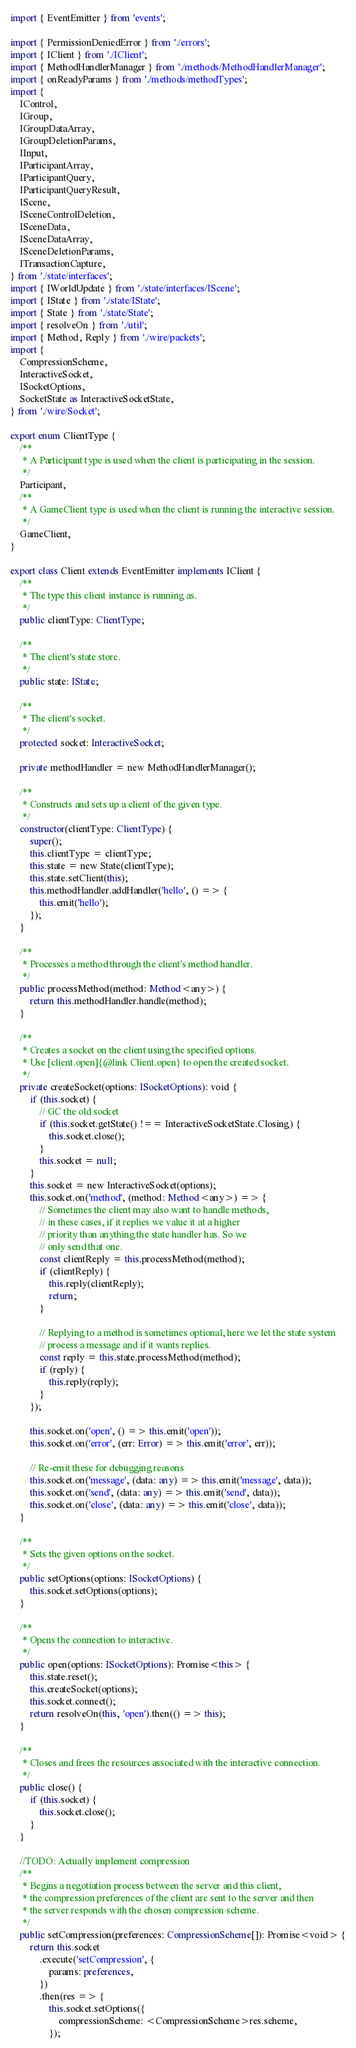<code> <loc_0><loc_0><loc_500><loc_500><_TypeScript_>import { EventEmitter } from 'events';

import { PermissionDeniedError } from './errors';
import { IClient } from './IClient';
import { MethodHandlerManager } from './methods/MethodHandlerManager';
import { onReadyParams } from './methods/methodTypes';
import {
    IControl,
    IGroup,
    IGroupDataArray,
    IGroupDeletionParams,
    IInput,
    IParticipantArray,
    IParticipantQuery,
    IParticipantQueryResult,
    IScene,
    ISceneControlDeletion,
    ISceneData,
    ISceneDataArray,
    ISceneDeletionParams,
    ITransactionCapture,
} from './state/interfaces';
import { IWorldUpdate } from './state/interfaces/IScene';
import { IState } from './state/IState';
import { State } from './state/State';
import { resolveOn } from './util';
import { Method, Reply } from './wire/packets';
import {
    CompressionScheme,
    InteractiveSocket,
    ISocketOptions,
    SocketState as InteractiveSocketState,
} from './wire/Socket';

export enum ClientType {
    /**
     * A Participant type is used when the client is participating in the session.
     */
    Participant,
    /**
     * A GameClient type is used when the client is running the interactive session.
     */
    GameClient,
}

export class Client extends EventEmitter implements IClient {
    /**
     * The type this client instance is running as.
     */
    public clientType: ClientType;

    /**
     * The client's state store.
     */
    public state: IState;

    /**
     * The client's socket.
     */
    protected socket: InteractiveSocket;

    private methodHandler = new MethodHandlerManager();

    /**
     * Constructs and sets up a client of the given type.
     */
    constructor(clientType: ClientType) {
        super();
        this.clientType = clientType;
        this.state = new State(clientType);
        this.state.setClient(this);
        this.methodHandler.addHandler('hello', () => {
            this.emit('hello');
        });
    }

    /**
     * Processes a method through the client's method handler.
     */
    public processMethod(method: Method<any>) {
        return this.methodHandler.handle(method);
    }

    /**
     * Creates a socket on the client using the specified options.
     * Use [client.open]{@link Client.open} to open the created socket.
     */
    private createSocket(options: ISocketOptions): void {
        if (this.socket) {
            // GC the old socket
            if (this.socket.getState() !== InteractiveSocketState.Closing) {
                this.socket.close();
            }
            this.socket = null;
        }
        this.socket = new InteractiveSocket(options);
        this.socket.on('method', (method: Method<any>) => {
            // Sometimes the client may also want to handle methods,
            // in these cases, if it replies we value it at a higher
            // priority than anything the state handler has. So we
            // only send that one.
            const clientReply = this.processMethod(method);
            if (clientReply) {
                this.reply(clientReply);
                return;
            }

            // Replying to a method is sometimes optional, here we let the state system
            // process a message and if it wants replies.
            const reply = this.state.processMethod(method);
            if (reply) {
                this.reply(reply);
            }
        });

        this.socket.on('open', () => this.emit('open'));
        this.socket.on('error', (err: Error) => this.emit('error', err));

        // Re-emit these for debugging reasons
        this.socket.on('message', (data: any) => this.emit('message', data));
        this.socket.on('send', (data: any) => this.emit('send', data));
        this.socket.on('close', (data: any) => this.emit('close', data));
    }

    /**
     * Sets the given options on the socket.
     */
    public setOptions(options: ISocketOptions) {
        this.socket.setOptions(options);
    }

    /**
     * Opens the connection to interactive.
     */
    public open(options: ISocketOptions): Promise<this> {
        this.state.reset();
        this.createSocket(options);
        this.socket.connect();
        return resolveOn(this, 'open').then(() => this);
    }

    /**
     * Closes and frees the resources associated with the interactive connection.
     */
    public close() {
        if (this.socket) {
            this.socket.close();
        }
    }

    //TODO: Actually implement compression
    /**
     * Begins a negotiation process between the server and this client,
     * the compression preferences of the client are sent to the server and then
     * the server responds with the chosen compression scheme.
     */
    public setCompression(preferences: CompressionScheme[]): Promise<void> {
        return this.socket
            .execute('setCompression', {
                params: preferences,
            })
            .then(res => {
                this.socket.setOptions({
                    compressionScheme: <CompressionScheme>res.scheme,
                });</code> 